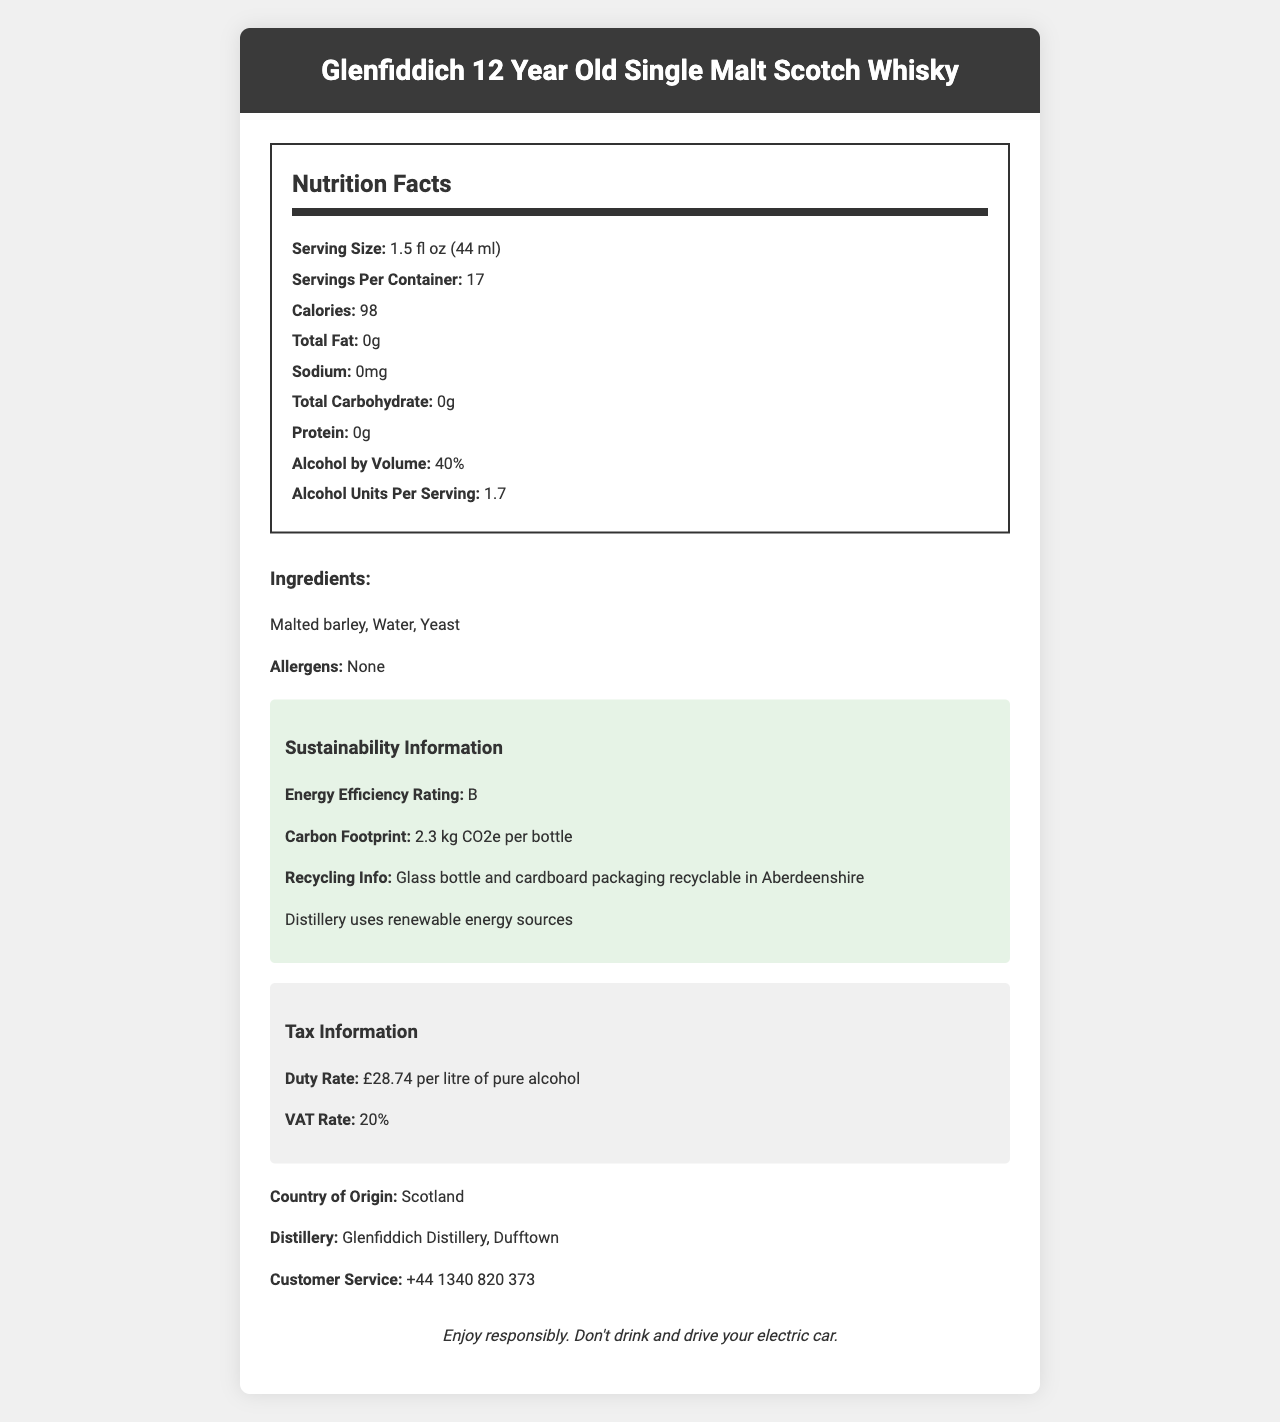what is the serving size for Glenfiddich 12 Year Old Single Malt Scotch Whisky? The document states that the serving size for Glenfiddich 12 Year Old Single Malt Scotch Whisky is 1.5 fl oz (44 ml).
Answer: 1.5 fl oz (44 ml) how many calories are in one serving of this whisky? The document specifies that each serving contains 98 calories.
Answer: 98 calories what is the alcohol by volume (ABV) percentage of this whisky? The document lists the alcohol by volume percentage as 40%.
Answer: 40% how many servings are there per container? This information is clearly stated in the document as 17 servings per container.
Answer: 17 does this whisky contain any allergens? The document indicates that there are no allergens in this whisky.
Answer: No what is the total carbohydrate content per serving? The total carbohydrate content per serving is listed as 0g in the document.
Answer: 0g what are the main ingredients of this whisky? According to the document, the main ingredients are malted barley, water, and yeast.
Answer: Malted barley, Water, Yeast where is Glenfiddich 12 Year Old Single Malt Scotch Whisky distilled? A. Aberfeldy Distillery B. Glenfiddich Distillery C. Oban Distillery D. Macallan Distillery The document specifies that the whisky is distilled at Glenfiddich Distillery, Dufftown.
Answer: B how should one dispose of the packaging for this whisky in Aberdeenshire? A. General Waste B. Organic Waste C. Recycling D. Hazardous Waste The document advises that the glass bottle and cardboard packaging are recyclable in Aberdeenshire.
Answer: C does this whisky have a high energy efficiency rating? The energy efficiency rating is 'B', which is not considered very high.
Answer: No should you drink this whisky and drive your electric car? The document contains a responsible drinking message that advises against drinking and driving.
Answer: No how many alcohol units are in each serving? It is mentioned in the document that there are 1.7 alcohol units per serving.
Answer: 1.7 is there any tax information mentioned in the document? The document contains details on the duty rate (£28.74 per litre of pure alcohol) and VAT rate (20%).
Answer: Yes can the carbon footprint of the whisky bottle be found in the document? The carbon footprint is listed as 2.3 kg CO2e per bottle.
Answer: Yes what is the contact number for customer service? The document lists the customer service contact number as +44 1340 820 373.
Answer: +44 1340 820 373 how much protein is there in each serving of this whisky? The document specifies that there is 0g of protein per serving.
Answer: 0g summary: describe the main details provided in the document about Glenfiddich 12 Year Old Single Malt Scotch Whisky. The details cover both nutritional facts and additional information like sustainability and tax information.
Answer: The document provides comprehensive details about Glenfiddich 12 Year Old Single Malt Scotch Whisky. It includes the serving size, calories per serving, alcohol content, and basic nutritional information such as fat, sodium, carbohydrate, and protein content, all of which are zero. It also lists the main ingredients (malted barley, water, yeast) and affirms the absence of allergens. The document highlights sustainability features like the recycling information and the carbon footprint. It outlines the duty and VAT rates, includes a responsible drinking message, and provides customer service contact information. what is the total fat content per serving? The document lists the total fat content as 0g per serving.
Answer: 0g what is the duty rate for Glenfiddich 12 Year Old Single Malt Scotch Whisky? The document specifies the duty rate as £28.74 per litre of pure alcohol.
Answer: £28.74 per litre of pure alcohol who is the producer of this whisky? The document does not provide explicit information regarding the producer of the whisky.
Answer: Cannot be determined 